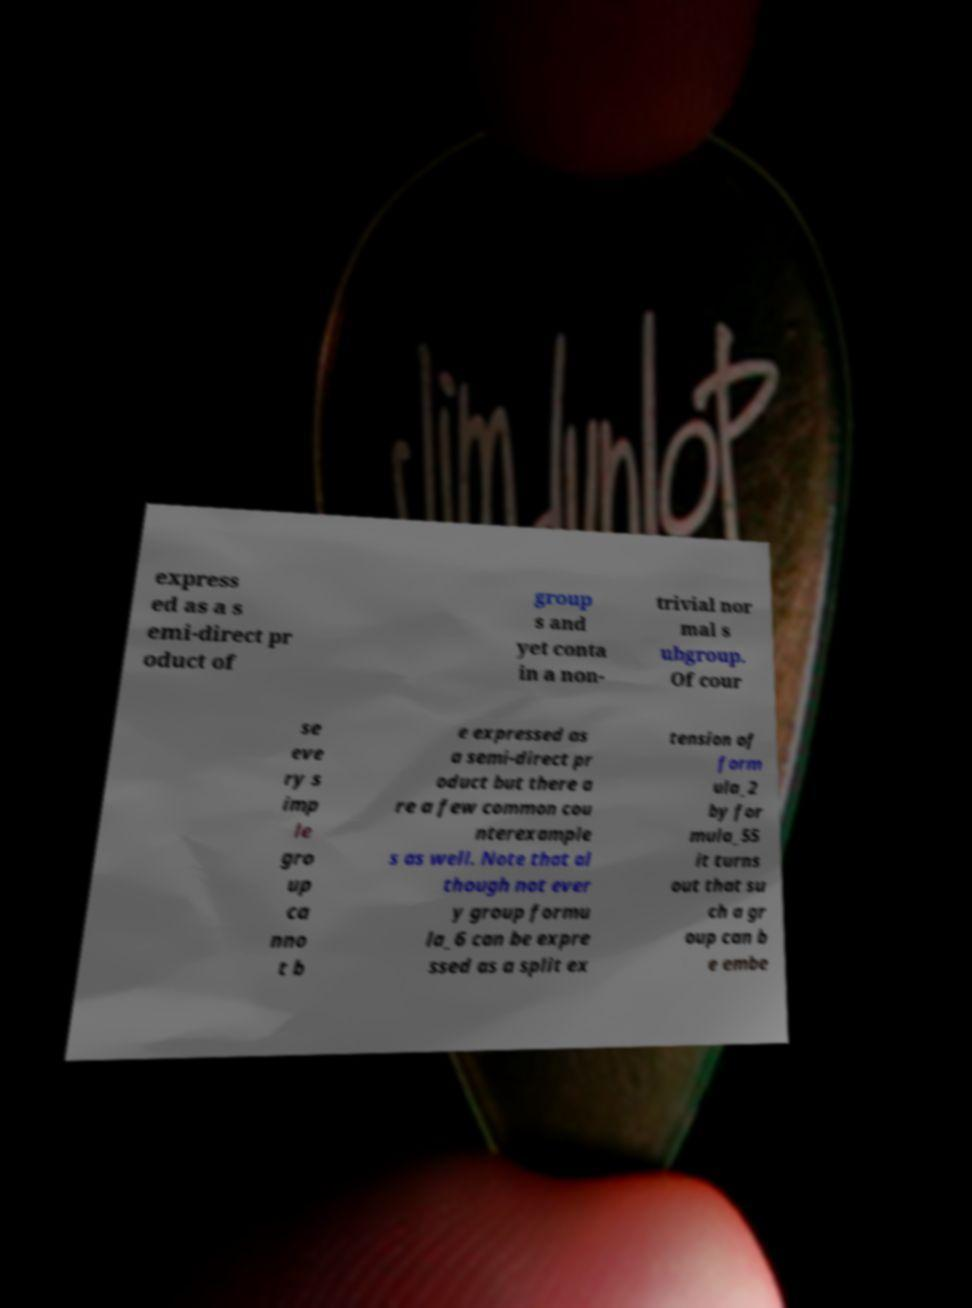Could you extract and type out the text from this image? express ed as a s emi-direct pr oduct of group s and yet conta in a non- trivial nor mal s ubgroup. Of cour se eve ry s imp le gro up ca nno t b e expressed as a semi-direct pr oduct but there a re a few common cou nterexample s as well. Note that al though not ever y group formu la_6 can be expre ssed as a split ex tension of form ula_2 by for mula_55 it turns out that su ch a gr oup can b e embe 